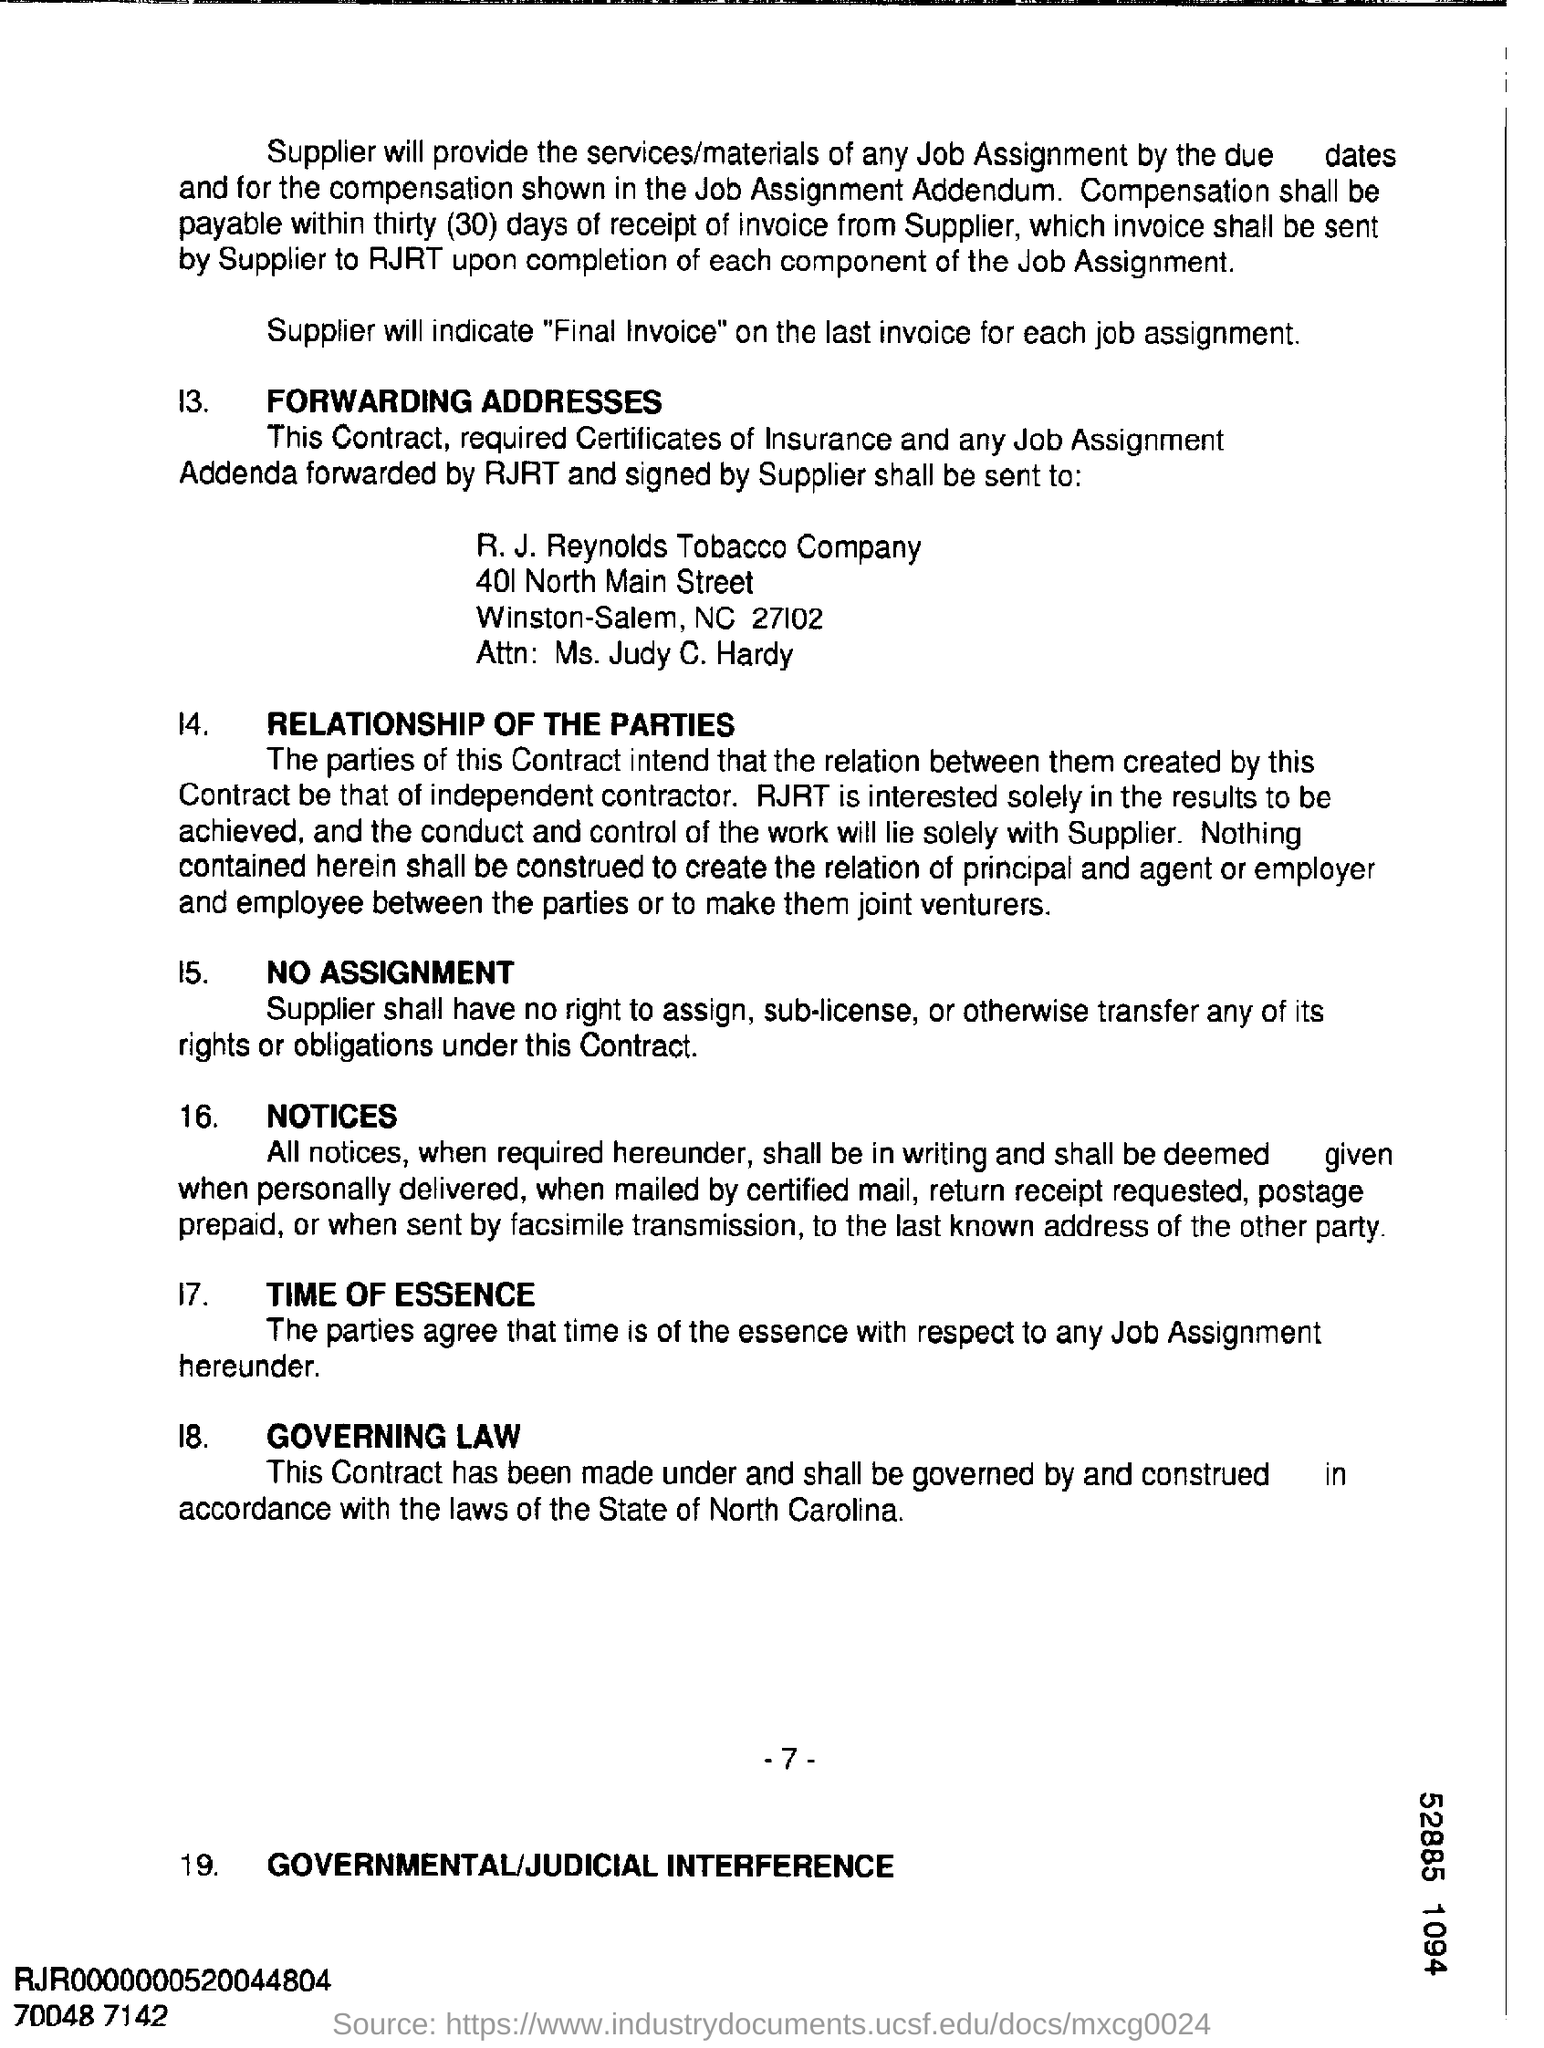Point out several critical features in this image. In the bottom right corner of the number 52885, the digit is 1094. 